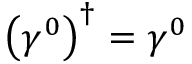Convert formula to latex. <formula><loc_0><loc_0><loc_500><loc_500>\left ( \gamma ^ { 0 } \right ) ^ { \dagger } = \gamma ^ { 0 }</formula> 